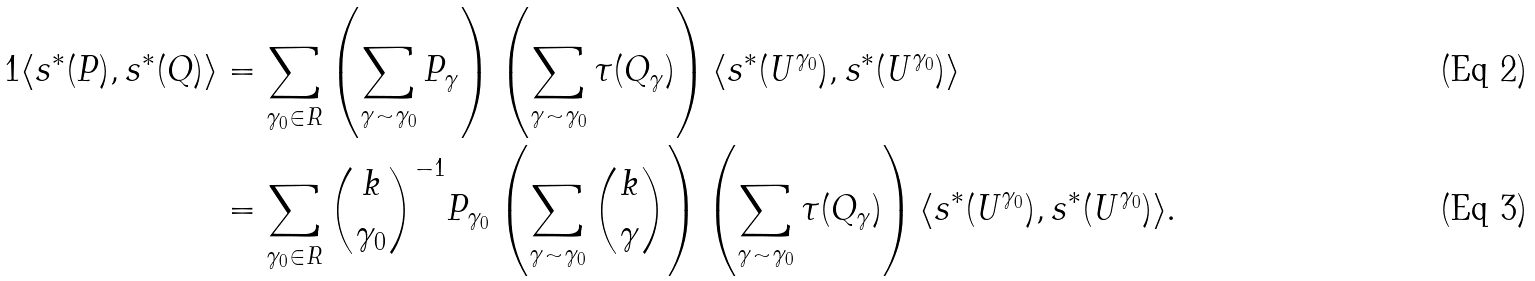<formula> <loc_0><loc_0><loc_500><loc_500>1 \langle s ^ { * } ( P ) , s ^ { * } ( Q ) \rangle & = \sum _ { \gamma _ { 0 } \in R } \left ( \sum _ { \gamma \sim \gamma _ { 0 } } P _ { \gamma } \right ) \left ( \sum _ { \gamma \sim \gamma _ { 0 } } { \tau ( Q _ { \gamma } ) } \right ) \langle s ^ { * } ( { U } ^ { \gamma _ { 0 } } ) , s ^ { * } ( { U } ^ { \gamma _ { 0 } } ) \rangle \\ & = \sum _ { \gamma _ { 0 } \in R } { k \choose \gamma _ { 0 } } ^ { - 1 } P _ { \gamma _ { 0 } } \left ( \sum _ { \gamma \sim \gamma _ { 0 } } { k \choose \gamma } \right ) \left ( \sum _ { \gamma \sim \gamma _ { 0 } } { \tau ( Q _ { \gamma } ) } \right ) \langle s ^ { * } ( { U } ^ { \gamma _ { 0 } } ) , s ^ { * } ( { U } ^ { \gamma _ { 0 } } ) \rangle .</formula> 